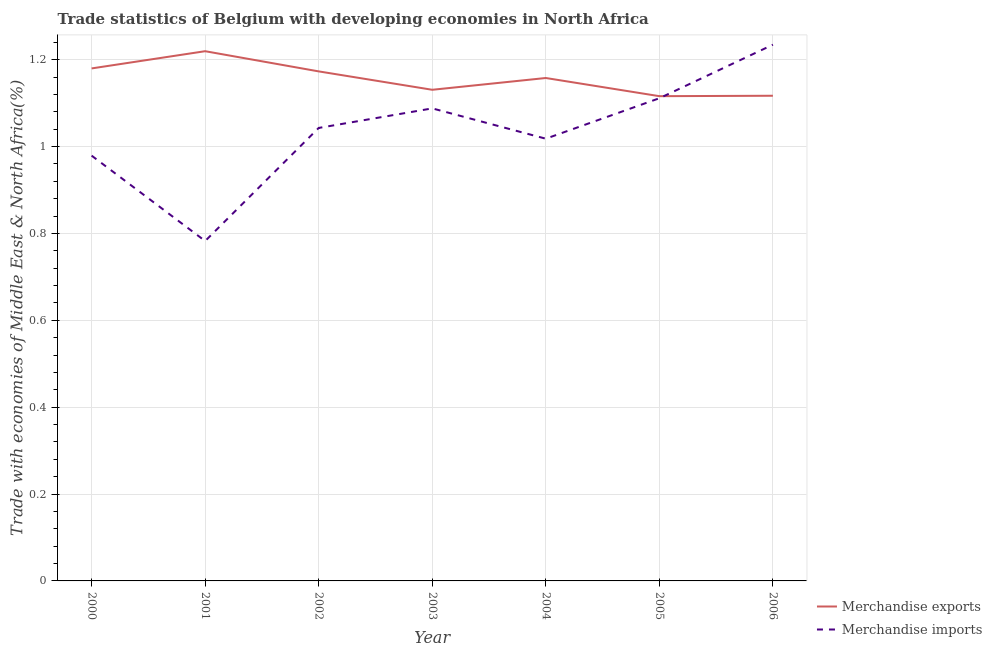Does the line corresponding to merchandise imports intersect with the line corresponding to merchandise exports?
Provide a short and direct response. Yes. Is the number of lines equal to the number of legend labels?
Keep it short and to the point. Yes. What is the merchandise imports in 2004?
Ensure brevity in your answer.  1.02. Across all years, what is the maximum merchandise imports?
Make the answer very short. 1.23. Across all years, what is the minimum merchandise exports?
Your response must be concise. 1.12. What is the total merchandise exports in the graph?
Make the answer very short. 8.09. What is the difference between the merchandise exports in 2002 and that in 2005?
Ensure brevity in your answer.  0.06. What is the difference between the merchandise imports in 2006 and the merchandise exports in 2005?
Your response must be concise. 0.12. What is the average merchandise exports per year?
Ensure brevity in your answer.  1.16. In the year 2001, what is the difference between the merchandise imports and merchandise exports?
Provide a succinct answer. -0.44. What is the ratio of the merchandise imports in 2000 to that in 2001?
Keep it short and to the point. 1.25. Is the merchandise imports in 2000 less than that in 2002?
Your answer should be compact. Yes. Is the difference between the merchandise imports in 2000 and 2003 greater than the difference between the merchandise exports in 2000 and 2003?
Ensure brevity in your answer.  No. What is the difference between the highest and the second highest merchandise exports?
Your answer should be compact. 0.04. What is the difference between the highest and the lowest merchandise exports?
Your answer should be compact. 0.1. In how many years, is the merchandise exports greater than the average merchandise exports taken over all years?
Your response must be concise. 4. Does the merchandise exports monotonically increase over the years?
Provide a short and direct response. No. Where does the legend appear in the graph?
Offer a terse response. Bottom right. What is the title of the graph?
Keep it short and to the point. Trade statistics of Belgium with developing economies in North Africa. What is the label or title of the Y-axis?
Provide a succinct answer. Trade with economies of Middle East & North Africa(%). What is the Trade with economies of Middle East & North Africa(%) in Merchandise exports in 2000?
Your answer should be very brief. 1.18. What is the Trade with economies of Middle East & North Africa(%) in Merchandise imports in 2000?
Offer a terse response. 0.98. What is the Trade with economies of Middle East & North Africa(%) in Merchandise exports in 2001?
Keep it short and to the point. 1.22. What is the Trade with economies of Middle East & North Africa(%) in Merchandise imports in 2001?
Make the answer very short. 0.78. What is the Trade with economies of Middle East & North Africa(%) in Merchandise exports in 2002?
Provide a succinct answer. 1.17. What is the Trade with economies of Middle East & North Africa(%) of Merchandise imports in 2002?
Provide a succinct answer. 1.04. What is the Trade with economies of Middle East & North Africa(%) in Merchandise exports in 2003?
Keep it short and to the point. 1.13. What is the Trade with economies of Middle East & North Africa(%) of Merchandise imports in 2003?
Make the answer very short. 1.09. What is the Trade with economies of Middle East & North Africa(%) of Merchandise exports in 2004?
Give a very brief answer. 1.16. What is the Trade with economies of Middle East & North Africa(%) of Merchandise imports in 2004?
Provide a succinct answer. 1.02. What is the Trade with economies of Middle East & North Africa(%) in Merchandise exports in 2005?
Offer a terse response. 1.12. What is the Trade with economies of Middle East & North Africa(%) in Merchandise imports in 2005?
Give a very brief answer. 1.11. What is the Trade with economies of Middle East & North Africa(%) of Merchandise exports in 2006?
Provide a succinct answer. 1.12. What is the Trade with economies of Middle East & North Africa(%) of Merchandise imports in 2006?
Ensure brevity in your answer.  1.23. Across all years, what is the maximum Trade with economies of Middle East & North Africa(%) in Merchandise exports?
Provide a succinct answer. 1.22. Across all years, what is the maximum Trade with economies of Middle East & North Africa(%) in Merchandise imports?
Keep it short and to the point. 1.23. Across all years, what is the minimum Trade with economies of Middle East & North Africa(%) of Merchandise exports?
Ensure brevity in your answer.  1.12. Across all years, what is the minimum Trade with economies of Middle East & North Africa(%) in Merchandise imports?
Provide a short and direct response. 0.78. What is the total Trade with economies of Middle East & North Africa(%) in Merchandise exports in the graph?
Offer a very short reply. 8.09. What is the total Trade with economies of Middle East & North Africa(%) of Merchandise imports in the graph?
Offer a very short reply. 7.26. What is the difference between the Trade with economies of Middle East & North Africa(%) of Merchandise exports in 2000 and that in 2001?
Offer a terse response. -0.04. What is the difference between the Trade with economies of Middle East & North Africa(%) in Merchandise imports in 2000 and that in 2001?
Provide a succinct answer. 0.2. What is the difference between the Trade with economies of Middle East & North Africa(%) of Merchandise exports in 2000 and that in 2002?
Your answer should be compact. 0.01. What is the difference between the Trade with economies of Middle East & North Africa(%) in Merchandise imports in 2000 and that in 2002?
Provide a short and direct response. -0.06. What is the difference between the Trade with economies of Middle East & North Africa(%) of Merchandise exports in 2000 and that in 2003?
Make the answer very short. 0.05. What is the difference between the Trade with economies of Middle East & North Africa(%) of Merchandise imports in 2000 and that in 2003?
Provide a succinct answer. -0.11. What is the difference between the Trade with economies of Middle East & North Africa(%) in Merchandise exports in 2000 and that in 2004?
Your response must be concise. 0.02. What is the difference between the Trade with economies of Middle East & North Africa(%) of Merchandise imports in 2000 and that in 2004?
Make the answer very short. -0.04. What is the difference between the Trade with economies of Middle East & North Africa(%) in Merchandise exports in 2000 and that in 2005?
Offer a very short reply. 0.06. What is the difference between the Trade with economies of Middle East & North Africa(%) in Merchandise imports in 2000 and that in 2005?
Your response must be concise. -0.13. What is the difference between the Trade with economies of Middle East & North Africa(%) of Merchandise exports in 2000 and that in 2006?
Provide a short and direct response. 0.06. What is the difference between the Trade with economies of Middle East & North Africa(%) in Merchandise imports in 2000 and that in 2006?
Offer a very short reply. -0.26. What is the difference between the Trade with economies of Middle East & North Africa(%) of Merchandise exports in 2001 and that in 2002?
Keep it short and to the point. 0.05. What is the difference between the Trade with economies of Middle East & North Africa(%) of Merchandise imports in 2001 and that in 2002?
Give a very brief answer. -0.26. What is the difference between the Trade with economies of Middle East & North Africa(%) in Merchandise exports in 2001 and that in 2003?
Offer a very short reply. 0.09. What is the difference between the Trade with economies of Middle East & North Africa(%) of Merchandise imports in 2001 and that in 2003?
Your response must be concise. -0.31. What is the difference between the Trade with economies of Middle East & North Africa(%) in Merchandise exports in 2001 and that in 2004?
Your response must be concise. 0.06. What is the difference between the Trade with economies of Middle East & North Africa(%) in Merchandise imports in 2001 and that in 2004?
Provide a short and direct response. -0.24. What is the difference between the Trade with economies of Middle East & North Africa(%) of Merchandise exports in 2001 and that in 2005?
Give a very brief answer. 0.1. What is the difference between the Trade with economies of Middle East & North Africa(%) of Merchandise imports in 2001 and that in 2005?
Offer a very short reply. -0.33. What is the difference between the Trade with economies of Middle East & North Africa(%) in Merchandise exports in 2001 and that in 2006?
Your answer should be compact. 0.1. What is the difference between the Trade with economies of Middle East & North Africa(%) in Merchandise imports in 2001 and that in 2006?
Your response must be concise. -0.45. What is the difference between the Trade with economies of Middle East & North Africa(%) in Merchandise exports in 2002 and that in 2003?
Provide a succinct answer. 0.04. What is the difference between the Trade with economies of Middle East & North Africa(%) in Merchandise imports in 2002 and that in 2003?
Offer a very short reply. -0.04. What is the difference between the Trade with economies of Middle East & North Africa(%) of Merchandise exports in 2002 and that in 2004?
Your answer should be very brief. 0.02. What is the difference between the Trade with economies of Middle East & North Africa(%) in Merchandise imports in 2002 and that in 2004?
Give a very brief answer. 0.02. What is the difference between the Trade with economies of Middle East & North Africa(%) in Merchandise exports in 2002 and that in 2005?
Provide a succinct answer. 0.06. What is the difference between the Trade with economies of Middle East & North Africa(%) in Merchandise imports in 2002 and that in 2005?
Your answer should be very brief. -0.07. What is the difference between the Trade with economies of Middle East & North Africa(%) of Merchandise exports in 2002 and that in 2006?
Provide a short and direct response. 0.06. What is the difference between the Trade with economies of Middle East & North Africa(%) of Merchandise imports in 2002 and that in 2006?
Provide a short and direct response. -0.19. What is the difference between the Trade with economies of Middle East & North Africa(%) of Merchandise exports in 2003 and that in 2004?
Ensure brevity in your answer.  -0.03. What is the difference between the Trade with economies of Middle East & North Africa(%) in Merchandise imports in 2003 and that in 2004?
Give a very brief answer. 0.07. What is the difference between the Trade with economies of Middle East & North Africa(%) of Merchandise exports in 2003 and that in 2005?
Give a very brief answer. 0.01. What is the difference between the Trade with economies of Middle East & North Africa(%) of Merchandise imports in 2003 and that in 2005?
Provide a short and direct response. -0.02. What is the difference between the Trade with economies of Middle East & North Africa(%) in Merchandise exports in 2003 and that in 2006?
Keep it short and to the point. 0.01. What is the difference between the Trade with economies of Middle East & North Africa(%) of Merchandise imports in 2003 and that in 2006?
Give a very brief answer. -0.15. What is the difference between the Trade with economies of Middle East & North Africa(%) in Merchandise exports in 2004 and that in 2005?
Your response must be concise. 0.04. What is the difference between the Trade with economies of Middle East & North Africa(%) of Merchandise imports in 2004 and that in 2005?
Your response must be concise. -0.09. What is the difference between the Trade with economies of Middle East & North Africa(%) in Merchandise exports in 2004 and that in 2006?
Your answer should be very brief. 0.04. What is the difference between the Trade with economies of Middle East & North Africa(%) of Merchandise imports in 2004 and that in 2006?
Offer a very short reply. -0.22. What is the difference between the Trade with economies of Middle East & North Africa(%) of Merchandise exports in 2005 and that in 2006?
Offer a very short reply. -0. What is the difference between the Trade with economies of Middle East & North Africa(%) of Merchandise imports in 2005 and that in 2006?
Keep it short and to the point. -0.12. What is the difference between the Trade with economies of Middle East & North Africa(%) in Merchandise exports in 2000 and the Trade with economies of Middle East & North Africa(%) in Merchandise imports in 2001?
Keep it short and to the point. 0.4. What is the difference between the Trade with economies of Middle East & North Africa(%) of Merchandise exports in 2000 and the Trade with economies of Middle East & North Africa(%) of Merchandise imports in 2002?
Make the answer very short. 0.14. What is the difference between the Trade with economies of Middle East & North Africa(%) in Merchandise exports in 2000 and the Trade with economies of Middle East & North Africa(%) in Merchandise imports in 2003?
Your answer should be very brief. 0.09. What is the difference between the Trade with economies of Middle East & North Africa(%) in Merchandise exports in 2000 and the Trade with economies of Middle East & North Africa(%) in Merchandise imports in 2004?
Offer a very short reply. 0.16. What is the difference between the Trade with economies of Middle East & North Africa(%) in Merchandise exports in 2000 and the Trade with economies of Middle East & North Africa(%) in Merchandise imports in 2005?
Offer a terse response. 0.07. What is the difference between the Trade with economies of Middle East & North Africa(%) of Merchandise exports in 2000 and the Trade with economies of Middle East & North Africa(%) of Merchandise imports in 2006?
Your answer should be compact. -0.05. What is the difference between the Trade with economies of Middle East & North Africa(%) of Merchandise exports in 2001 and the Trade with economies of Middle East & North Africa(%) of Merchandise imports in 2002?
Ensure brevity in your answer.  0.18. What is the difference between the Trade with economies of Middle East & North Africa(%) of Merchandise exports in 2001 and the Trade with economies of Middle East & North Africa(%) of Merchandise imports in 2003?
Offer a terse response. 0.13. What is the difference between the Trade with economies of Middle East & North Africa(%) in Merchandise exports in 2001 and the Trade with economies of Middle East & North Africa(%) in Merchandise imports in 2004?
Your answer should be very brief. 0.2. What is the difference between the Trade with economies of Middle East & North Africa(%) in Merchandise exports in 2001 and the Trade with economies of Middle East & North Africa(%) in Merchandise imports in 2005?
Your answer should be compact. 0.11. What is the difference between the Trade with economies of Middle East & North Africa(%) in Merchandise exports in 2001 and the Trade with economies of Middle East & North Africa(%) in Merchandise imports in 2006?
Offer a very short reply. -0.01. What is the difference between the Trade with economies of Middle East & North Africa(%) in Merchandise exports in 2002 and the Trade with economies of Middle East & North Africa(%) in Merchandise imports in 2003?
Make the answer very short. 0.09. What is the difference between the Trade with economies of Middle East & North Africa(%) of Merchandise exports in 2002 and the Trade with economies of Middle East & North Africa(%) of Merchandise imports in 2004?
Your answer should be very brief. 0.15. What is the difference between the Trade with economies of Middle East & North Africa(%) in Merchandise exports in 2002 and the Trade with economies of Middle East & North Africa(%) in Merchandise imports in 2005?
Provide a short and direct response. 0.06. What is the difference between the Trade with economies of Middle East & North Africa(%) of Merchandise exports in 2002 and the Trade with economies of Middle East & North Africa(%) of Merchandise imports in 2006?
Your response must be concise. -0.06. What is the difference between the Trade with economies of Middle East & North Africa(%) of Merchandise exports in 2003 and the Trade with economies of Middle East & North Africa(%) of Merchandise imports in 2004?
Give a very brief answer. 0.11. What is the difference between the Trade with economies of Middle East & North Africa(%) of Merchandise exports in 2003 and the Trade with economies of Middle East & North Africa(%) of Merchandise imports in 2005?
Offer a very short reply. 0.02. What is the difference between the Trade with economies of Middle East & North Africa(%) of Merchandise exports in 2003 and the Trade with economies of Middle East & North Africa(%) of Merchandise imports in 2006?
Offer a terse response. -0.1. What is the difference between the Trade with economies of Middle East & North Africa(%) in Merchandise exports in 2004 and the Trade with economies of Middle East & North Africa(%) in Merchandise imports in 2005?
Your answer should be compact. 0.05. What is the difference between the Trade with economies of Middle East & North Africa(%) in Merchandise exports in 2004 and the Trade with economies of Middle East & North Africa(%) in Merchandise imports in 2006?
Keep it short and to the point. -0.08. What is the difference between the Trade with economies of Middle East & North Africa(%) in Merchandise exports in 2005 and the Trade with economies of Middle East & North Africa(%) in Merchandise imports in 2006?
Offer a terse response. -0.12. What is the average Trade with economies of Middle East & North Africa(%) in Merchandise exports per year?
Ensure brevity in your answer.  1.16. What is the average Trade with economies of Middle East & North Africa(%) of Merchandise imports per year?
Offer a very short reply. 1.04. In the year 2000, what is the difference between the Trade with economies of Middle East & North Africa(%) of Merchandise exports and Trade with economies of Middle East & North Africa(%) of Merchandise imports?
Your answer should be compact. 0.2. In the year 2001, what is the difference between the Trade with economies of Middle East & North Africa(%) of Merchandise exports and Trade with economies of Middle East & North Africa(%) of Merchandise imports?
Offer a terse response. 0.44. In the year 2002, what is the difference between the Trade with economies of Middle East & North Africa(%) of Merchandise exports and Trade with economies of Middle East & North Africa(%) of Merchandise imports?
Give a very brief answer. 0.13. In the year 2003, what is the difference between the Trade with economies of Middle East & North Africa(%) of Merchandise exports and Trade with economies of Middle East & North Africa(%) of Merchandise imports?
Offer a terse response. 0.04. In the year 2004, what is the difference between the Trade with economies of Middle East & North Africa(%) in Merchandise exports and Trade with economies of Middle East & North Africa(%) in Merchandise imports?
Your answer should be compact. 0.14. In the year 2005, what is the difference between the Trade with economies of Middle East & North Africa(%) of Merchandise exports and Trade with economies of Middle East & North Africa(%) of Merchandise imports?
Offer a very short reply. 0. In the year 2006, what is the difference between the Trade with economies of Middle East & North Africa(%) in Merchandise exports and Trade with economies of Middle East & North Africa(%) in Merchandise imports?
Offer a terse response. -0.12. What is the ratio of the Trade with economies of Middle East & North Africa(%) in Merchandise exports in 2000 to that in 2001?
Make the answer very short. 0.97. What is the ratio of the Trade with economies of Middle East & North Africa(%) in Merchandise imports in 2000 to that in 2001?
Your response must be concise. 1.25. What is the ratio of the Trade with economies of Middle East & North Africa(%) in Merchandise imports in 2000 to that in 2002?
Provide a short and direct response. 0.94. What is the ratio of the Trade with economies of Middle East & North Africa(%) in Merchandise exports in 2000 to that in 2003?
Your answer should be very brief. 1.04. What is the ratio of the Trade with economies of Middle East & North Africa(%) of Merchandise imports in 2000 to that in 2004?
Your response must be concise. 0.96. What is the ratio of the Trade with economies of Middle East & North Africa(%) of Merchandise exports in 2000 to that in 2005?
Offer a terse response. 1.06. What is the ratio of the Trade with economies of Middle East & North Africa(%) in Merchandise imports in 2000 to that in 2005?
Offer a very short reply. 0.88. What is the ratio of the Trade with economies of Middle East & North Africa(%) in Merchandise exports in 2000 to that in 2006?
Offer a terse response. 1.06. What is the ratio of the Trade with economies of Middle East & North Africa(%) in Merchandise imports in 2000 to that in 2006?
Your answer should be very brief. 0.79. What is the ratio of the Trade with economies of Middle East & North Africa(%) in Merchandise exports in 2001 to that in 2002?
Your answer should be very brief. 1.04. What is the ratio of the Trade with economies of Middle East & North Africa(%) of Merchandise imports in 2001 to that in 2002?
Provide a succinct answer. 0.75. What is the ratio of the Trade with economies of Middle East & North Africa(%) in Merchandise exports in 2001 to that in 2003?
Provide a succinct answer. 1.08. What is the ratio of the Trade with economies of Middle East & North Africa(%) of Merchandise imports in 2001 to that in 2003?
Make the answer very short. 0.72. What is the ratio of the Trade with economies of Middle East & North Africa(%) of Merchandise exports in 2001 to that in 2004?
Offer a terse response. 1.05. What is the ratio of the Trade with economies of Middle East & North Africa(%) in Merchandise imports in 2001 to that in 2004?
Provide a short and direct response. 0.77. What is the ratio of the Trade with economies of Middle East & North Africa(%) of Merchandise exports in 2001 to that in 2005?
Offer a very short reply. 1.09. What is the ratio of the Trade with economies of Middle East & North Africa(%) of Merchandise imports in 2001 to that in 2005?
Keep it short and to the point. 0.7. What is the ratio of the Trade with economies of Middle East & North Africa(%) in Merchandise exports in 2001 to that in 2006?
Provide a succinct answer. 1.09. What is the ratio of the Trade with economies of Middle East & North Africa(%) of Merchandise imports in 2001 to that in 2006?
Make the answer very short. 0.63. What is the ratio of the Trade with economies of Middle East & North Africa(%) of Merchandise exports in 2002 to that in 2003?
Provide a succinct answer. 1.04. What is the ratio of the Trade with economies of Middle East & North Africa(%) in Merchandise imports in 2002 to that in 2003?
Your answer should be compact. 0.96. What is the ratio of the Trade with economies of Middle East & North Africa(%) of Merchandise exports in 2002 to that in 2004?
Offer a terse response. 1.01. What is the ratio of the Trade with economies of Middle East & North Africa(%) of Merchandise imports in 2002 to that in 2004?
Make the answer very short. 1.02. What is the ratio of the Trade with economies of Middle East & North Africa(%) of Merchandise exports in 2002 to that in 2005?
Keep it short and to the point. 1.05. What is the ratio of the Trade with economies of Middle East & North Africa(%) of Merchandise imports in 2002 to that in 2005?
Give a very brief answer. 0.94. What is the ratio of the Trade with economies of Middle East & North Africa(%) in Merchandise exports in 2002 to that in 2006?
Your answer should be compact. 1.05. What is the ratio of the Trade with economies of Middle East & North Africa(%) of Merchandise imports in 2002 to that in 2006?
Your response must be concise. 0.84. What is the ratio of the Trade with economies of Middle East & North Africa(%) of Merchandise exports in 2003 to that in 2004?
Your answer should be very brief. 0.98. What is the ratio of the Trade with economies of Middle East & North Africa(%) of Merchandise imports in 2003 to that in 2004?
Keep it short and to the point. 1.07. What is the ratio of the Trade with economies of Middle East & North Africa(%) in Merchandise exports in 2003 to that in 2005?
Make the answer very short. 1.01. What is the ratio of the Trade with economies of Middle East & North Africa(%) of Merchandise exports in 2003 to that in 2006?
Provide a short and direct response. 1.01. What is the ratio of the Trade with economies of Middle East & North Africa(%) in Merchandise imports in 2003 to that in 2006?
Give a very brief answer. 0.88. What is the ratio of the Trade with economies of Middle East & North Africa(%) of Merchandise exports in 2004 to that in 2005?
Offer a terse response. 1.04. What is the ratio of the Trade with economies of Middle East & North Africa(%) of Merchandise imports in 2004 to that in 2005?
Ensure brevity in your answer.  0.92. What is the ratio of the Trade with economies of Middle East & North Africa(%) of Merchandise exports in 2004 to that in 2006?
Keep it short and to the point. 1.04. What is the ratio of the Trade with economies of Middle East & North Africa(%) of Merchandise imports in 2004 to that in 2006?
Provide a short and direct response. 0.82. What is the ratio of the Trade with economies of Middle East & North Africa(%) in Merchandise exports in 2005 to that in 2006?
Your response must be concise. 1. What is the ratio of the Trade with economies of Middle East & North Africa(%) of Merchandise imports in 2005 to that in 2006?
Offer a terse response. 0.9. What is the difference between the highest and the second highest Trade with economies of Middle East & North Africa(%) of Merchandise exports?
Your answer should be very brief. 0.04. What is the difference between the highest and the second highest Trade with economies of Middle East & North Africa(%) of Merchandise imports?
Offer a very short reply. 0.12. What is the difference between the highest and the lowest Trade with economies of Middle East & North Africa(%) of Merchandise exports?
Keep it short and to the point. 0.1. What is the difference between the highest and the lowest Trade with economies of Middle East & North Africa(%) of Merchandise imports?
Give a very brief answer. 0.45. 